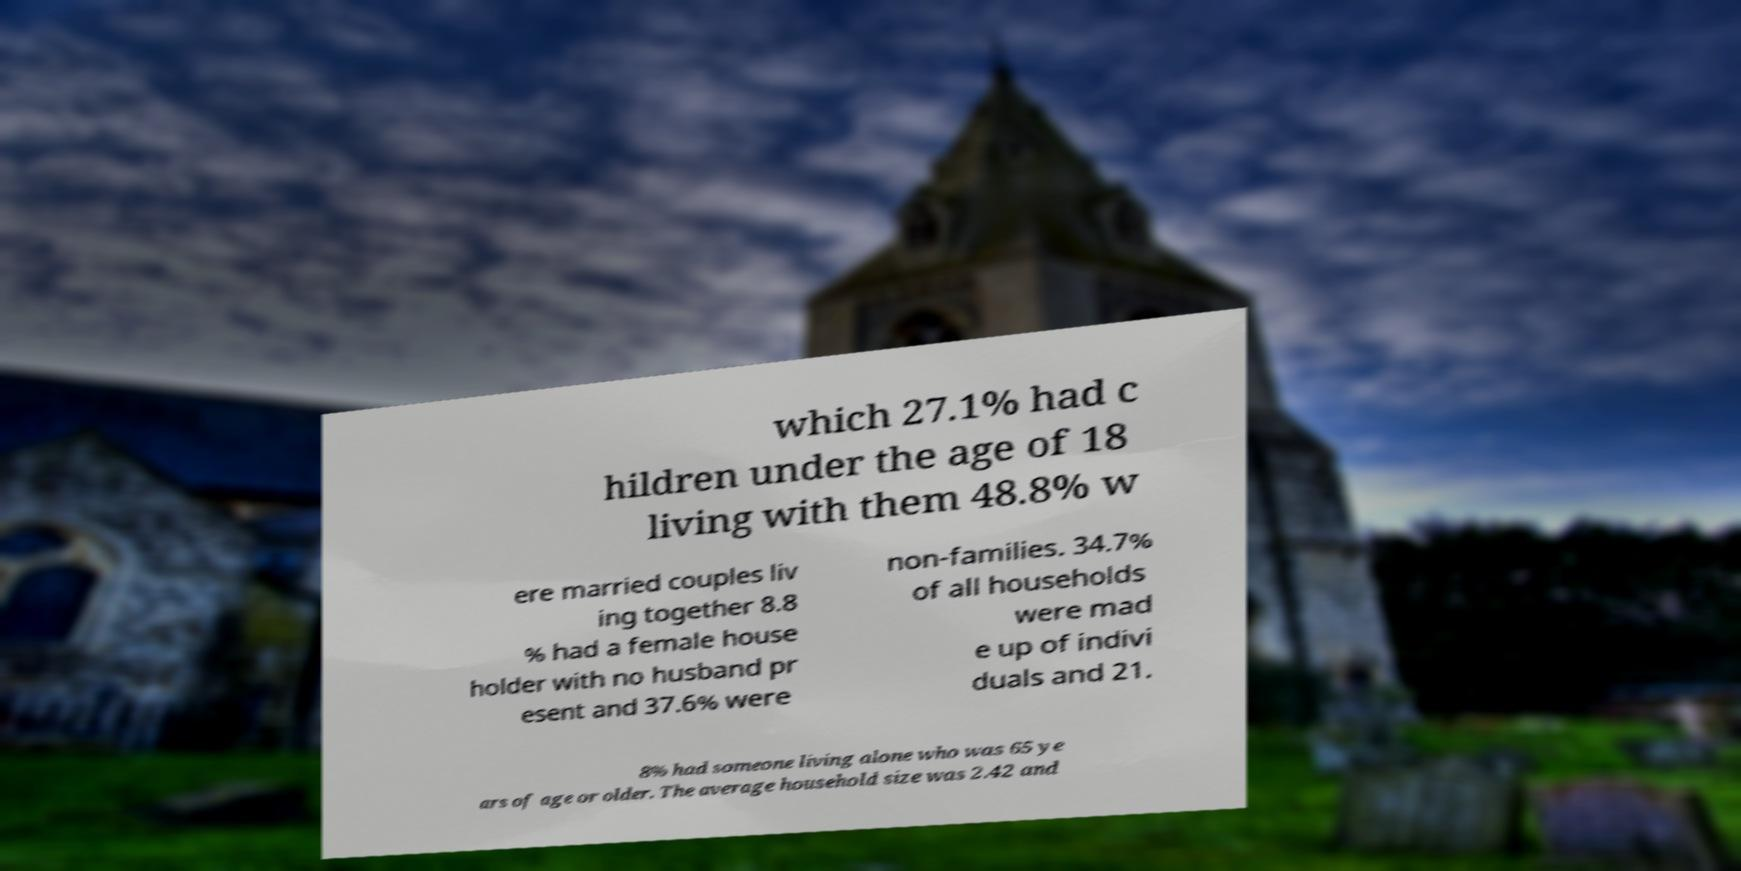I need the written content from this picture converted into text. Can you do that? which 27.1% had c hildren under the age of 18 living with them 48.8% w ere married couples liv ing together 8.8 % had a female house holder with no husband pr esent and 37.6% were non-families. 34.7% of all households were mad e up of indivi duals and 21. 8% had someone living alone who was 65 ye ars of age or older. The average household size was 2.42 and 